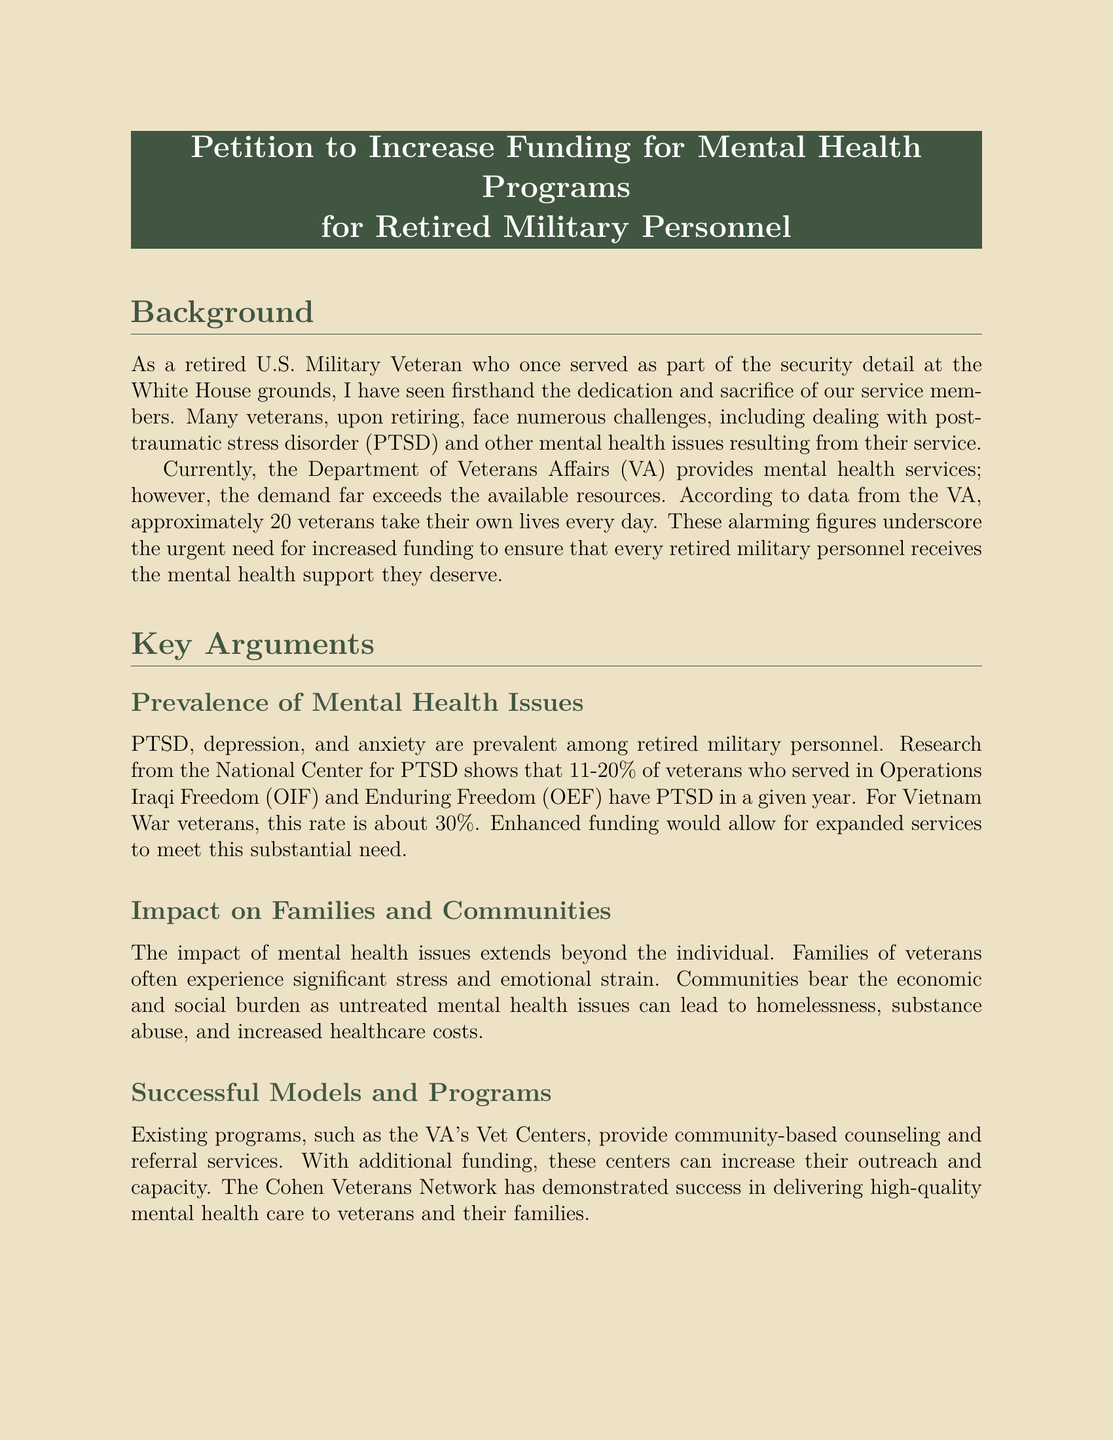What are the mental health issues prevalent among retired military personnel? The document states that PTSD, depression, and anxiety are prevalent among retired military personnel.
Answer: PTSD, depression, anxiety How many veterans take their own lives every day? The document mentions that approximately 20 veterans take their own lives every day.
Answer: 20 What is the PTSD rate for veterans who served in Operations Iraqi Freedom? The document indicates that the PTSD rate for veterans who served in Operations Iraqi Freedom is 11-20%.
Answer: 11-20% Which organization has demonstrated success in delivering high-quality mental health care to veterans? The document references the Cohen Veterans Network as a successful organization in this regard.
Answer: Cohen Veterans Network How much could treating PTSD and major depression in veterans save annually in healthcare costs? According to the document, treating PTSD and major depression in veterans could lead to annual savings of $2 billion in healthcare costs.
Answer: $2 billion What is the primary call to action in the document? The document calls upon the U.S. Congress to significantly increase funding for mental health programs dedicated to retired military personnel.
Answer: Increase funding What is the impact of untreated mental health issues on families? The document states that families of veterans often experience significant stress and emotional strain due to untreated mental health issues.
Answer: Significant stress and emotional strain What is the purpose of the petition? The purpose of the petition is to increase funding for mental health programs for retired military personnel.
Answer: Increase funding for mental health programs What organization provides community-based counseling and referral services? The document mentions that the VA's Vet Centers provide community-based counseling and referral services.
Answer: VA's Vet Centers 